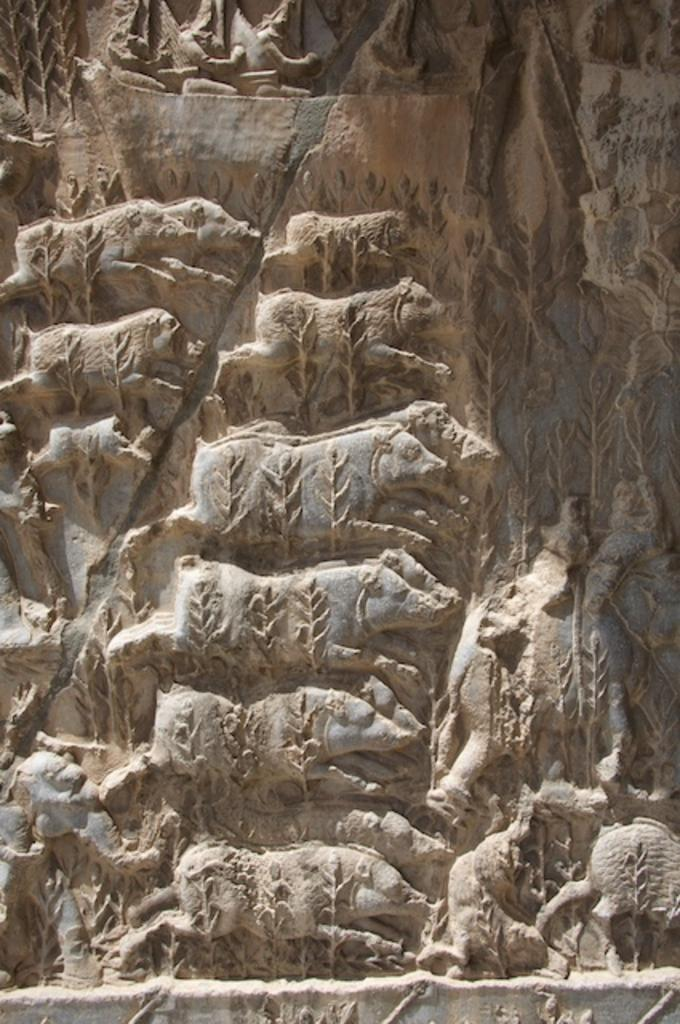What is depicted on the rock in the image? There is a carving of an animal on a rock in the image. What colors can be seen on the rock? The rock has brown and grey colors. What type of clover is growing on the rock in the image? There is no clover present in the image; it only features a carving of an animal on a rock with brown and grey colors. 